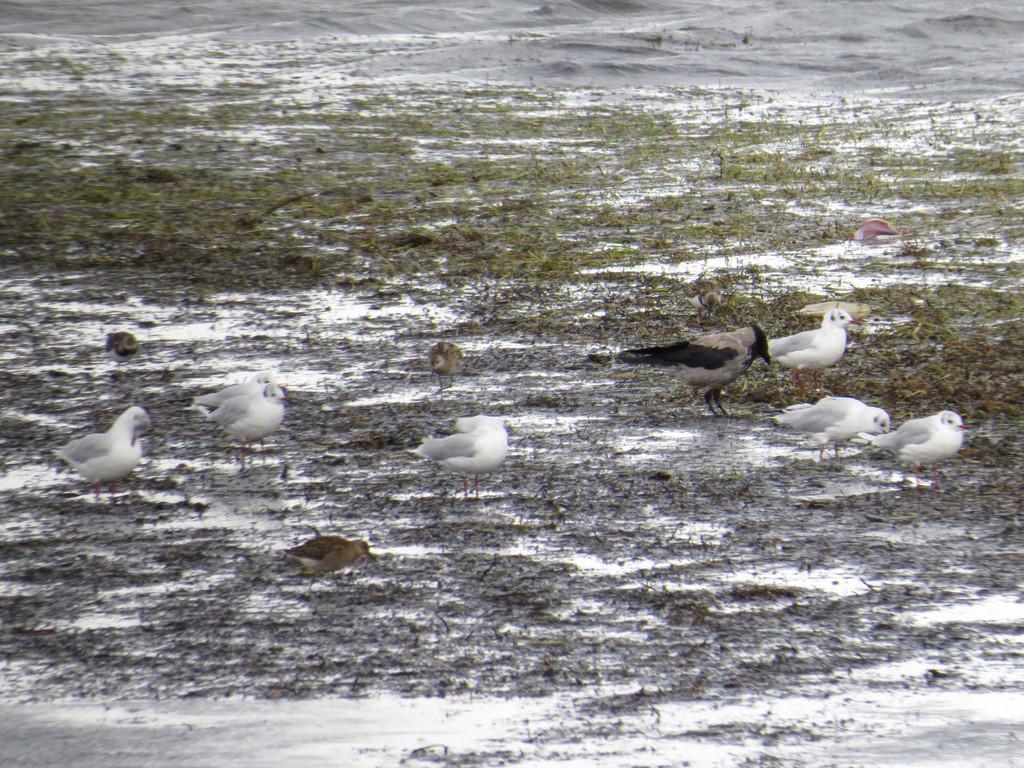In one or two sentences, can you explain what this image depicts? In this image there are birds and grass. 